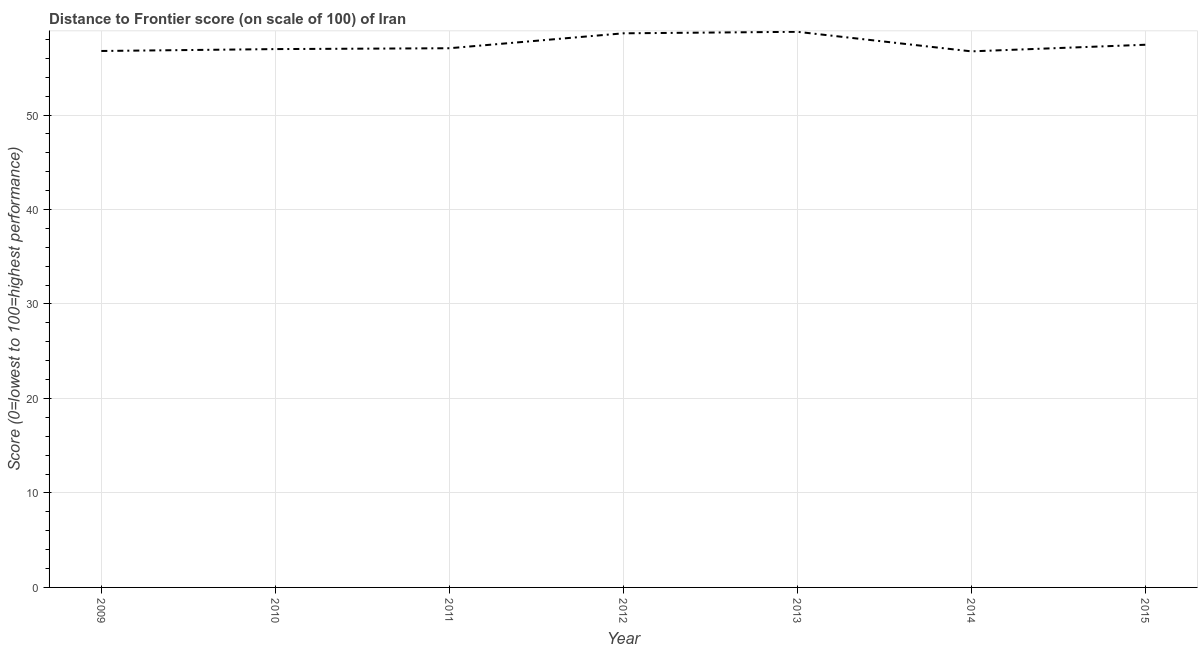What is the distance to frontier score in 2014?
Provide a succinct answer. 56.74. Across all years, what is the maximum distance to frontier score?
Provide a succinct answer. 58.81. Across all years, what is the minimum distance to frontier score?
Your response must be concise. 56.74. What is the sum of the distance to frontier score?
Provide a short and direct response. 402.47. What is the difference between the distance to frontier score in 2012 and 2014?
Ensure brevity in your answer.  1.91. What is the average distance to frontier score per year?
Your response must be concise. 57.5. What is the median distance to frontier score?
Your answer should be compact. 57.07. In how many years, is the distance to frontier score greater than 12 ?
Offer a terse response. 7. Do a majority of the years between 2009 and 2012 (inclusive) have distance to frontier score greater than 20 ?
Your answer should be very brief. Yes. What is the ratio of the distance to frontier score in 2009 to that in 2011?
Provide a short and direct response. 0.99. Is the difference between the distance to frontier score in 2012 and 2013 greater than the difference between any two years?
Give a very brief answer. No. What is the difference between the highest and the second highest distance to frontier score?
Ensure brevity in your answer.  0.16. Is the sum of the distance to frontier score in 2012 and 2015 greater than the maximum distance to frontier score across all years?
Ensure brevity in your answer.  Yes. What is the difference between the highest and the lowest distance to frontier score?
Keep it short and to the point. 2.07. In how many years, is the distance to frontier score greater than the average distance to frontier score taken over all years?
Give a very brief answer. 2. How many lines are there?
Your answer should be compact. 1. Does the graph contain any zero values?
Give a very brief answer. No. Does the graph contain grids?
Your answer should be compact. Yes. What is the title of the graph?
Provide a succinct answer. Distance to Frontier score (on scale of 100) of Iran. What is the label or title of the X-axis?
Ensure brevity in your answer.  Year. What is the label or title of the Y-axis?
Your response must be concise. Score (0=lowest to 100=highest performance). What is the Score (0=lowest to 100=highest performance) in 2009?
Keep it short and to the point. 56.78. What is the Score (0=lowest to 100=highest performance) in 2010?
Give a very brief answer. 56.98. What is the Score (0=lowest to 100=highest performance) of 2011?
Your response must be concise. 57.07. What is the Score (0=lowest to 100=highest performance) of 2012?
Make the answer very short. 58.65. What is the Score (0=lowest to 100=highest performance) of 2013?
Your answer should be very brief. 58.81. What is the Score (0=lowest to 100=highest performance) in 2014?
Your response must be concise. 56.74. What is the Score (0=lowest to 100=highest performance) in 2015?
Your response must be concise. 57.44. What is the difference between the Score (0=lowest to 100=highest performance) in 2009 and 2011?
Your response must be concise. -0.29. What is the difference between the Score (0=lowest to 100=highest performance) in 2009 and 2012?
Ensure brevity in your answer.  -1.87. What is the difference between the Score (0=lowest to 100=highest performance) in 2009 and 2013?
Give a very brief answer. -2.03. What is the difference between the Score (0=lowest to 100=highest performance) in 2009 and 2014?
Your answer should be compact. 0.04. What is the difference between the Score (0=lowest to 100=highest performance) in 2009 and 2015?
Make the answer very short. -0.66. What is the difference between the Score (0=lowest to 100=highest performance) in 2010 and 2011?
Offer a terse response. -0.09. What is the difference between the Score (0=lowest to 100=highest performance) in 2010 and 2012?
Offer a terse response. -1.67. What is the difference between the Score (0=lowest to 100=highest performance) in 2010 and 2013?
Your answer should be compact. -1.83. What is the difference between the Score (0=lowest to 100=highest performance) in 2010 and 2014?
Your response must be concise. 0.24. What is the difference between the Score (0=lowest to 100=highest performance) in 2010 and 2015?
Ensure brevity in your answer.  -0.46. What is the difference between the Score (0=lowest to 100=highest performance) in 2011 and 2012?
Make the answer very short. -1.58. What is the difference between the Score (0=lowest to 100=highest performance) in 2011 and 2013?
Ensure brevity in your answer.  -1.74. What is the difference between the Score (0=lowest to 100=highest performance) in 2011 and 2014?
Your response must be concise. 0.33. What is the difference between the Score (0=lowest to 100=highest performance) in 2011 and 2015?
Provide a succinct answer. -0.37. What is the difference between the Score (0=lowest to 100=highest performance) in 2012 and 2013?
Keep it short and to the point. -0.16. What is the difference between the Score (0=lowest to 100=highest performance) in 2012 and 2014?
Offer a terse response. 1.91. What is the difference between the Score (0=lowest to 100=highest performance) in 2012 and 2015?
Give a very brief answer. 1.21. What is the difference between the Score (0=lowest to 100=highest performance) in 2013 and 2014?
Your answer should be very brief. 2.07. What is the difference between the Score (0=lowest to 100=highest performance) in 2013 and 2015?
Provide a succinct answer. 1.37. What is the difference between the Score (0=lowest to 100=highest performance) in 2014 and 2015?
Your answer should be very brief. -0.7. What is the ratio of the Score (0=lowest to 100=highest performance) in 2009 to that in 2011?
Give a very brief answer. 0.99. What is the ratio of the Score (0=lowest to 100=highest performance) in 2009 to that in 2013?
Your answer should be very brief. 0.96. What is the ratio of the Score (0=lowest to 100=highest performance) in 2009 to that in 2015?
Make the answer very short. 0.99. What is the ratio of the Score (0=lowest to 100=highest performance) in 2010 to that in 2011?
Your answer should be compact. 1. What is the ratio of the Score (0=lowest to 100=highest performance) in 2010 to that in 2012?
Give a very brief answer. 0.97. What is the ratio of the Score (0=lowest to 100=highest performance) in 2011 to that in 2015?
Ensure brevity in your answer.  0.99. What is the ratio of the Score (0=lowest to 100=highest performance) in 2012 to that in 2013?
Your answer should be very brief. 1. What is the ratio of the Score (0=lowest to 100=highest performance) in 2012 to that in 2014?
Keep it short and to the point. 1.03. What is the ratio of the Score (0=lowest to 100=highest performance) in 2012 to that in 2015?
Offer a terse response. 1.02. What is the ratio of the Score (0=lowest to 100=highest performance) in 2013 to that in 2014?
Provide a succinct answer. 1.04. What is the ratio of the Score (0=lowest to 100=highest performance) in 2014 to that in 2015?
Provide a succinct answer. 0.99. 